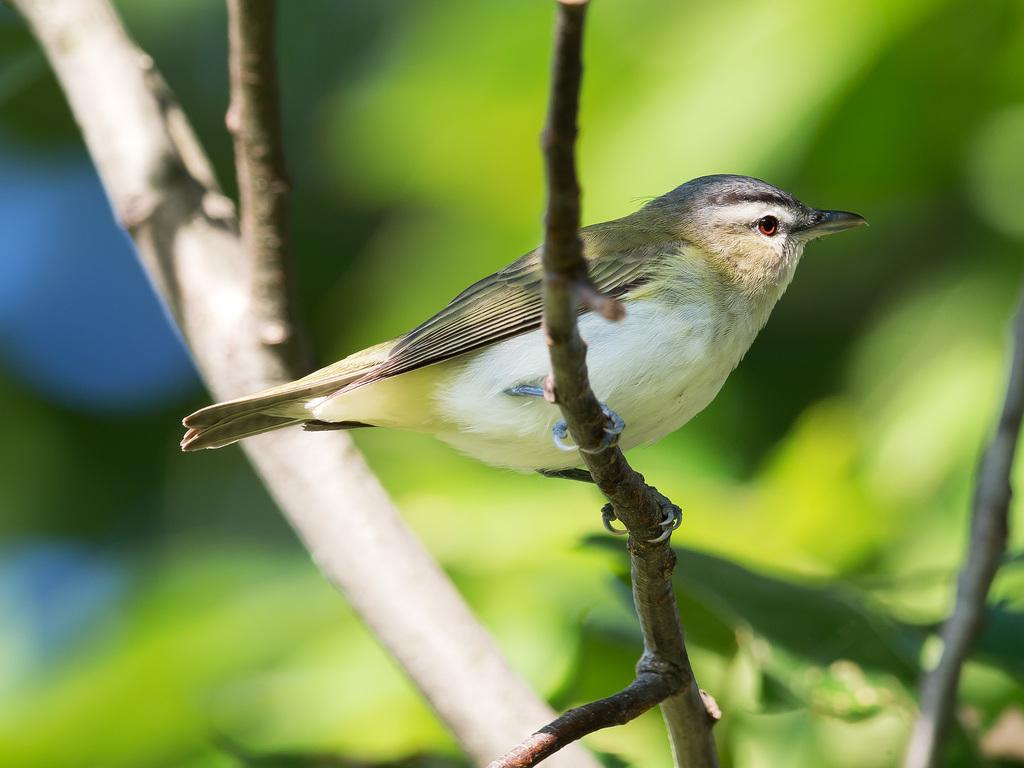What type of animal is in the image? There is a bird in the image. Where is the bird located? The bird is on a stem. What colors can be seen in the background of the image? The background of the image has blue and green colors. What type of lead is the bird using to communicate with the minister in the image? There is no lead or minister present in the image; it only features a bird on a stem with a blue and green background. 